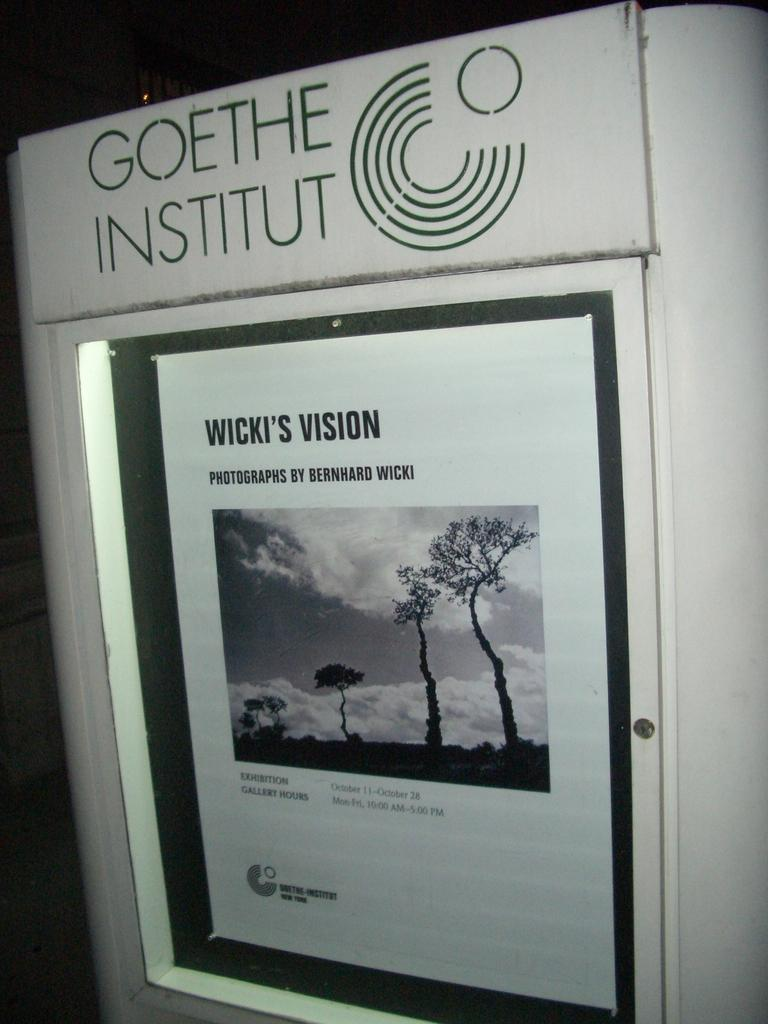What is the main subject of the image? There is an object in the image. What is inside the object? The object contains a photograph and some text. What type of bell is present in the image? There is no bell present in the image. Who is the manager of the object in the image? The concept of a manager does not apply to the object in the image, as it is not a business or organization. --- 